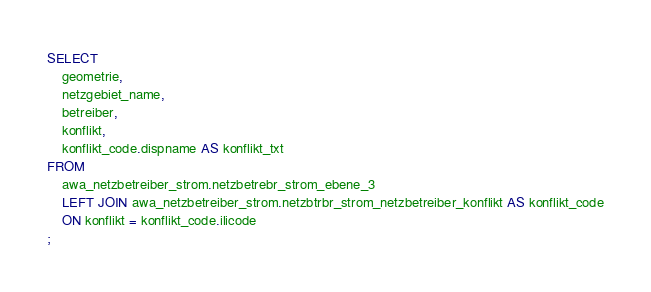<code> <loc_0><loc_0><loc_500><loc_500><_SQL_>SELECT 
    geometrie, 
    netzgebiet_name, 
    betreiber,  
    konflikt,
    konflikt_code.dispname AS konflikt_txt
FROM 
    awa_netzbetreiber_strom.netzbetrebr_strom_ebene_3
    LEFT JOIN awa_netzbetreiber_strom.netzbtrbr_strom_netzbetreiber_konflikt AS konflikt_code
    ON konflikt = konflikt_code.ilicode
;
</code> 